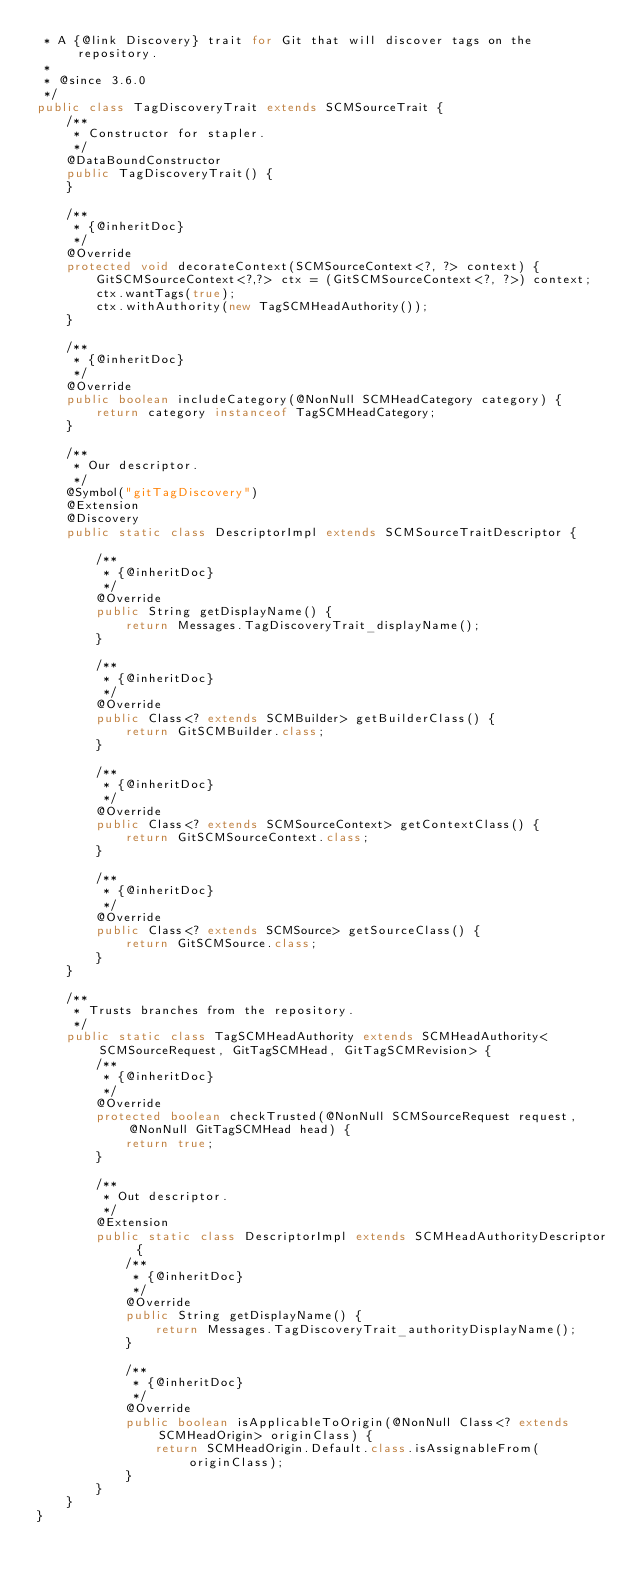Convert code to text. <code><loc_0><loc_0><loc_500><loc_500><_Java_> * A {@link Discovery} trait for Git that will discover tags on the repository.
 *
 * @since 3.6.0
 */
public class TagDiscoveryTrait extends SCMSourceTrait {
    /**
     * Constructor for stapler.
     */
    @DataBoundConstructor
    public TagDiscoveryTrait() {
    }

    /**
     * {@inheritDoc}
     */
    @Override
    protected void decorateContext(SCMSourceContext<?, ?> context) {
        GitSCMSourceContext<?,?> ctx = (GitSCMSourceContext<?, ?>) context;
        ctx.wantTags(true);
        ctx.withAuthority(new TagSCMHeadAuthority());
    }

    /**
     * {@inheritDoc}
     */
    @Override
    public boolean includeCategory(@NonNull SCMHeadCategory category) {
        return category instanceof TagSCMHeadCategory;
    }

    /**
     * Our descriptor.
     */
    @Symbol("gitTagDiscovery")
    @Extension
    @Discovery
    public static class DescriptorImpl extends SCMSourceTraitDescriptor {

        /**
         * {@inheritDoc}
         */
        @Override
        public String getDisplayName() {
            return Messages.TagDiscoveryTrait_displayName();
        }

        /**
         * {@inheritDoc}
         */
        @Override
        public Class<? extends SCMBuilder> getBuilderClass() {
            return GitSCMBuilder.class;
        }

        /**
         * {@inheritDoc}
         */
        @Override
        public Class<? extends SCMSourceContext> getContextClass() {
            return GitSCMSourceContext.class;
        }

        /**
         * {@inheritDoc}
         */
        @Override
        public Class<? extends SCMSource> getSourceClass() {
            return GitSCMSource.class;
        }
    }

    /**
     * Trusts branches from the repository.
     */
    public static class TagSCMHeadAuthority extends SCMHeadAuthority<SCMSourceRequest, GitTagSCMHead, GitTagSCMRevision> {
        /**
         * {@inheritDoc}
         */
        @Override
        protected boolean checkTrusted(@NonNull SCMSourceRequest request, @NonNull GitTagSCMHead head) {
            return true;
        }

        /**
         * Out descriptor.
         */
        @Extension
        public static class DescriptorImpl extends SCMHeadAuthorityDescriptor {
            /**
             * {@inheritDoc}
             */
            @Override
            public String getDisplayName() {
                return Messages.TagDiscoveryTrait_authorityDisplayName();
            }

            /**
             * {@inheritDoc}
             */
            @Override
            public boolean isApplicableToOrigin(@NonNull Class<? extends SCMHeadOrigin> originClass) {
                return SCMHeadOrigin.Default.class.isAssignableFrom(originClass);
            }
        }
    }
}
</code> 